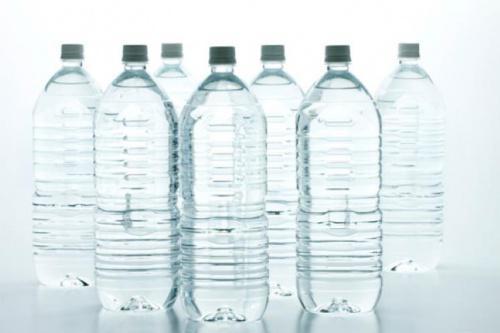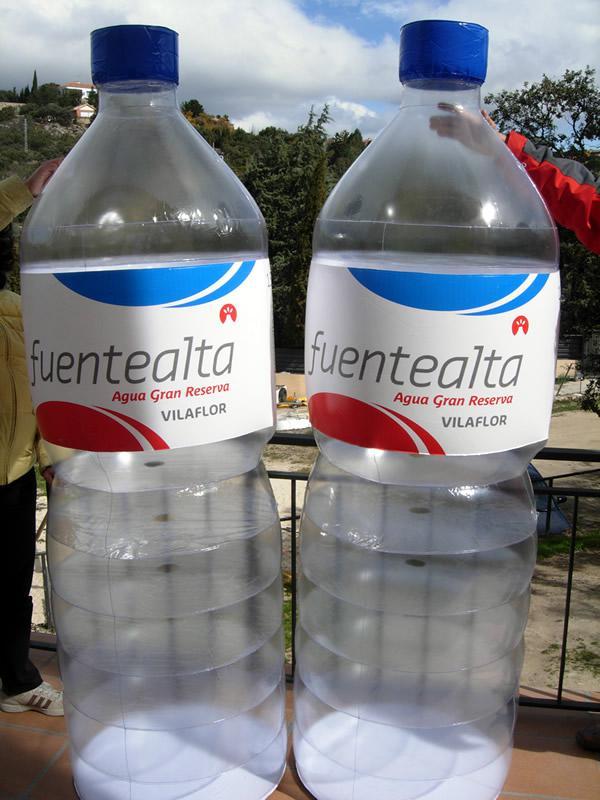The first image is the image on the left, the second image is the image on the right. Analyze the images presented: Is the assertion "An image shows exactly two lidded, unlabeled water bottles of the same size and shape, displayed level and side-by-side." valid? Answer yes or no. No. The first image is the image on the left, the second image is the image on the right. Evaluate the accuracy of this statement regarding the images: "There are five bottles in total.". Is it true? Answer yes or no. No. 